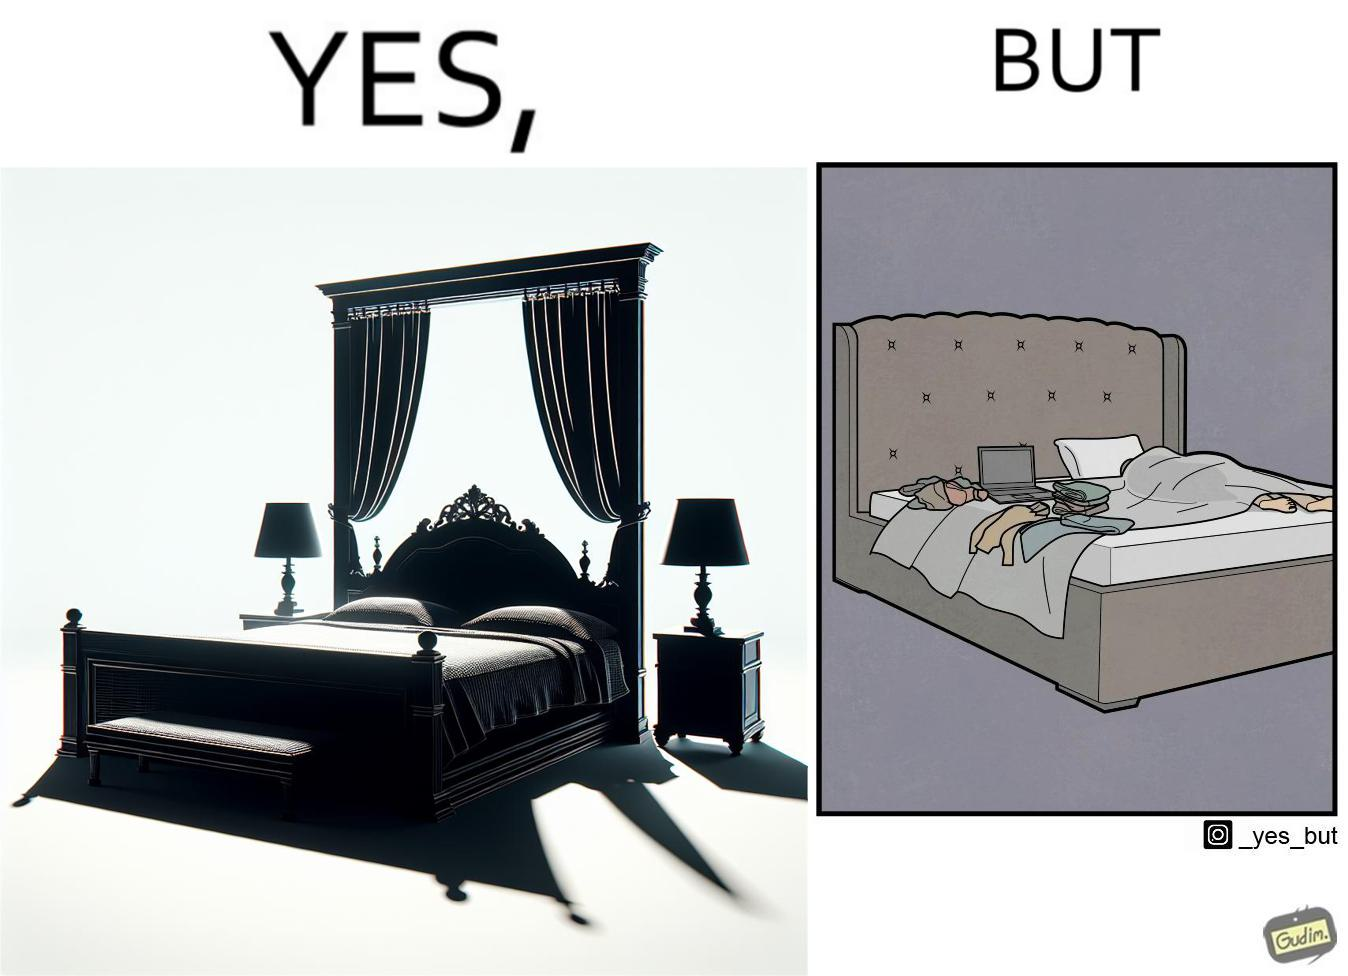Explain the humor or irony in this image. Although the person has purchased a king size bed, but only less than half of the space is used by the person for sleeping. 